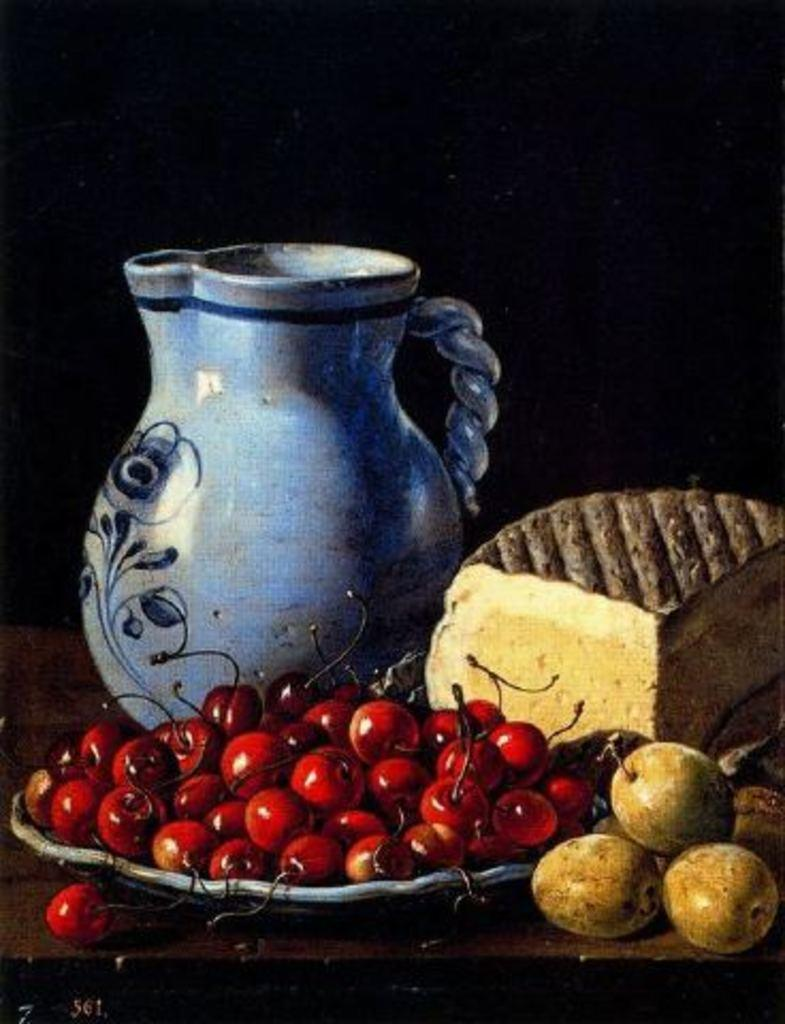What is located in the center of the image? There is a jar in the center of the image. What other food items can be seen in the image? There are fruits on a plate and a cake in the image. Can you see a kitty playing with the fruits on the plate in the image? There is no kitty present in the image, and therefore no such activity can be observed. Is there a plough visible in the image? There is no plough present in the image. 